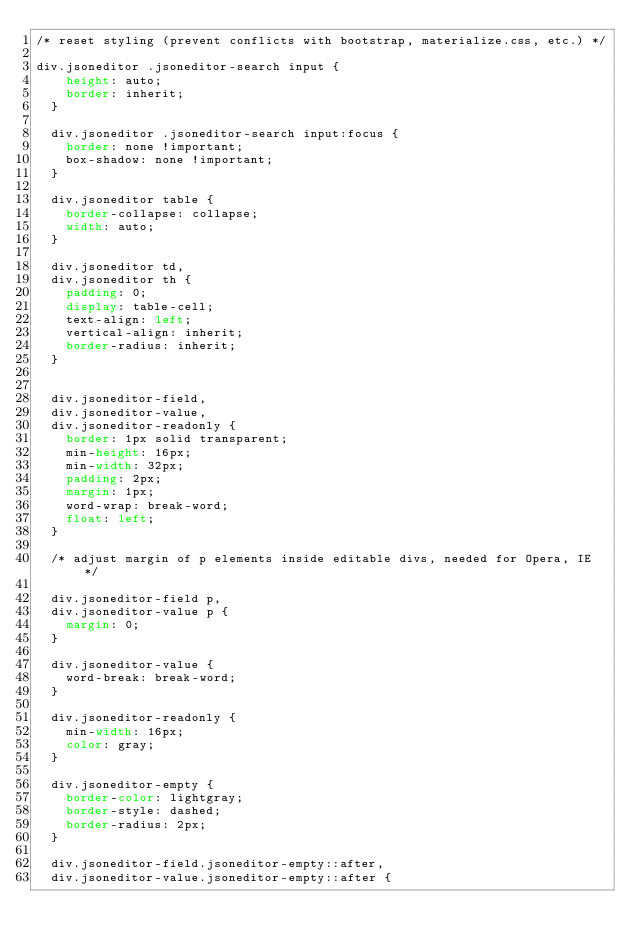<code> <loc_0><loc_0><loc_500><loc_500><_CSS_>/* reset styling (prevent conflicts with bootstrap, materialize.css, etc.) */

div.jsoneditor .jsoneditor-search input {
    height: auto;
    border: inherit;
  }
  
  div.jsoneditor .jsoneditor-search input:focus {
    border: none !important;
    box-shadow: none !important;
  }
  
  div.jsoneditor table {
    border-collapse: collapse;
    width: auto;
  }
  
  div.jsoneditor td,
  div.jsoneditor th {
    padding: 0;
    display: table-cell;
    text-align: left;
    vertical-align: inherit;
    border-radius: inherit;
  }
  
  
  div.jsoneditor-field,
  div.jsoneditor-value,
  div.jsoneditor-readonly {
    border: 1px solid transparent;
    min-height: 16px;
    min-width: 32px;
    padding: 2px;
    margin: 1px;
    word-wrap: break-word;
    float: left;
  }
  
  /* adjust margin of p elements inside editable divs, needed for Opera, IE */
  
  div.jsoneditor-field p,
  div.jsoneditor-value p {
    margin: 0;
  }
  
  div.jsoneditor-value {
    word-break: break-word;
  }
  
  div.jsoneditor-readonly {
    min-width: 16px;
    color: gray;
  }
  
  div.jsoneditor-empty {
    border-color: lightgray;
    border-style: dashed;
    border-radius: 2px;
  }
  
  div.jsoneditor-field.jsoneditor-empty::after,
  div.jsoneditor-value.jsoneditor-empty::after {</code> 